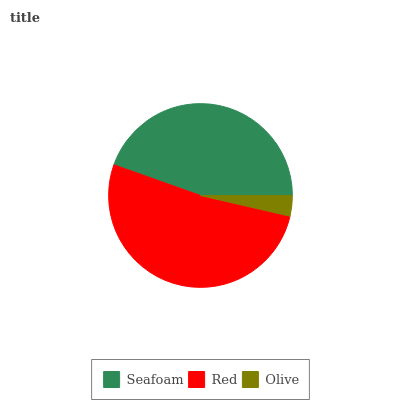Is Olive the minimum?
Answer yes or no. Yes. Is Red the maximum?
Answer yes or no. Yes. Is Red the minimum?
Answer yes or no. No. Is Olive the maximum?
Answer yes or no. No. Is Red greater than Olive?
Answer yes or no. Yes. Is Olive less than Red?
Answer yes or no. Yes. Is Olive greater than Red?
Answer yes or no. No. Is Red less than Olive?
Answer yes or no. No. Is Seafoam the high median?
Answer yes or no. Yes. Is Seafoam the low median?
Answer yes or no. Yes. Is Olive the high median?
Answer yes or no. No. Is Red the low median?
Answer yes or no. No. 